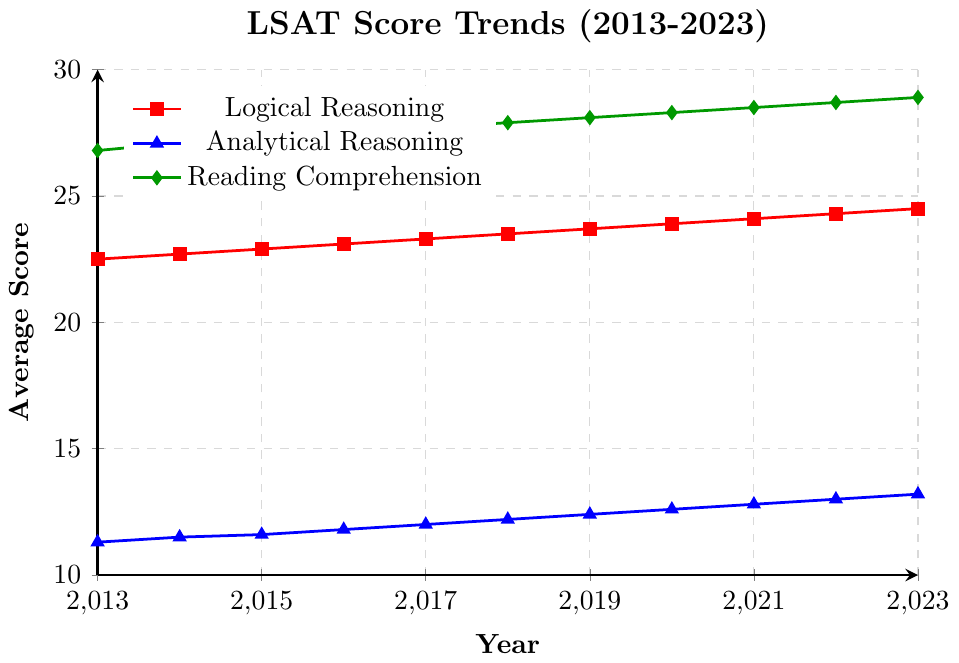What is the trend in the average Logical Reasoning scores from 2013 to 2023? To find the trend, look at the line corresponding to Logical Reasoning (red line with square markers). The scores consistently increase from 22.5 in 2013 to 24.5 in 2023, indicating a steady upward trend.
Answer: Steady upward trend Which section shows the highest scores consistently over the years? By examining the chart, we can see that the Reading Comprehension section (green line with diamond markers) consistently has the highest scores compared to the other sections from 2013 to 2023.
Answer: Reading Comprehension What is the difference between the average scores of Reading Comprehension and Analytical Reasoning in 2023? The average score for Reading Comprehension in 2023 is 28.9, and for Analytical Reasoning, it is 13.2. The difference is calculated as 28.9 - 13.2 = 15.7.
Answer: 15.7 In which year did Logical Reasoning scores surpass 24 for the first time? Check the red line with square markers for Logical Reasoning. The scores cross 24 in 2022 when the score is 24.3.
Answer: 2022 What is the growth in Analytical Reasoning scores from 2013 to 2020? The score in Analytical Reasoning was 11.3 in 2013 and 12.6 in 2020. The growth is calculated as 12.6 - 11.3 = 1.3.
Answer: 1.3 How much did Reading Comprehension scores increase each year on average from 2013 to 2023? Identify the increase over the period (28.9 in 2023 - 26.8 in 2013 = 2.1), then divide by the number of years (2023 - 2013 = 10 years). The average yearly increase is 2.1 / 10 = 0.21.
Answer: 0.21 Did any section’s scores drop at any point from 2013 to 2023? By examining all the lines closely, no section shows a decrease in scores at any point; all lines indicate consistent increases over time.
Answer: No 